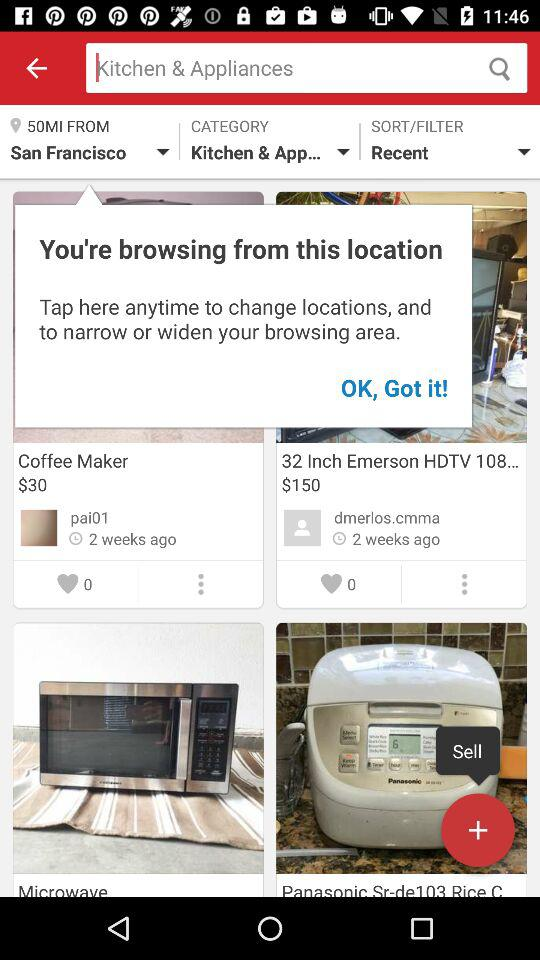What is the selected location? The selected location is San Francisco. 